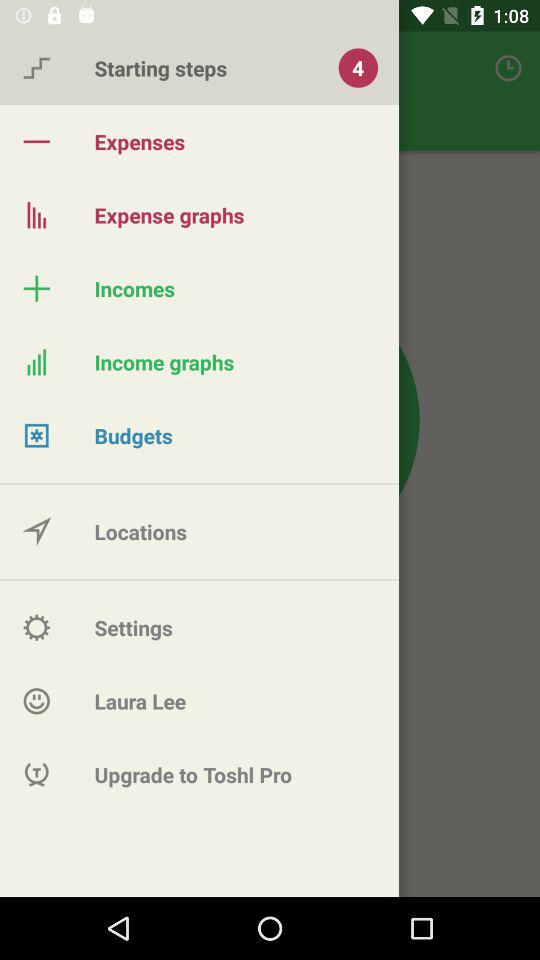How many notifications are in the starting steps? There are 4 notifications. 